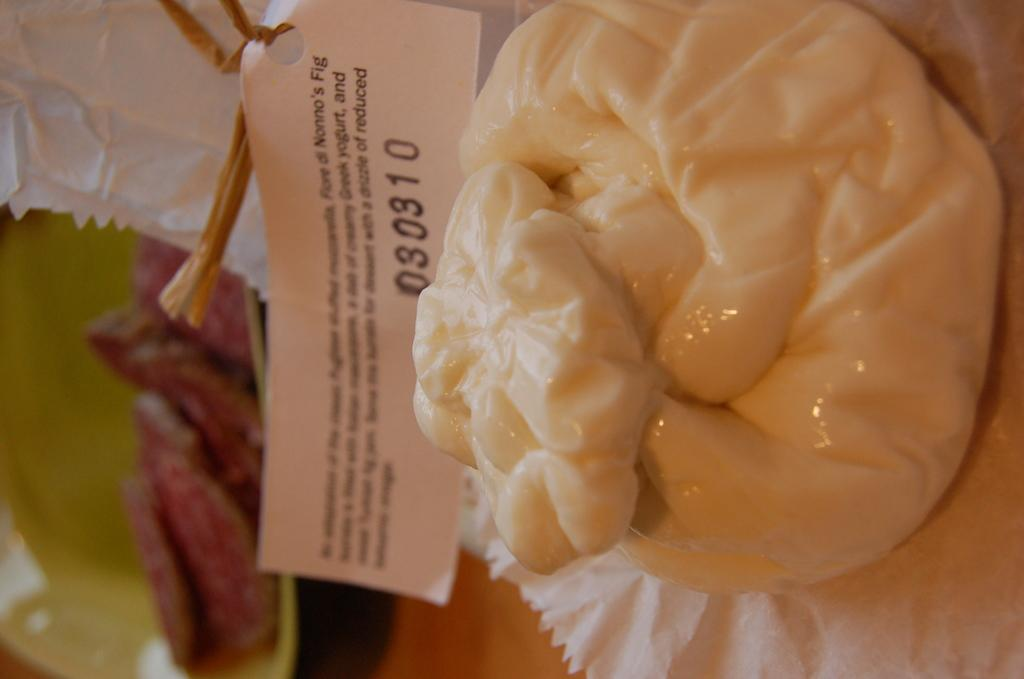What type of food can be seen in the image? The food in the image is in cream color. What is the food placed on? The food is on white color paper. Is there any dishware visible in the image? Yes, there is a plate in the image, which is in green color. Who is the expert in the image? There is no expert present in the image; it features food on a plate. What type of basket is used to hold the food in the image? There is no basket present in the image; the food is on white paper and a green plate. 